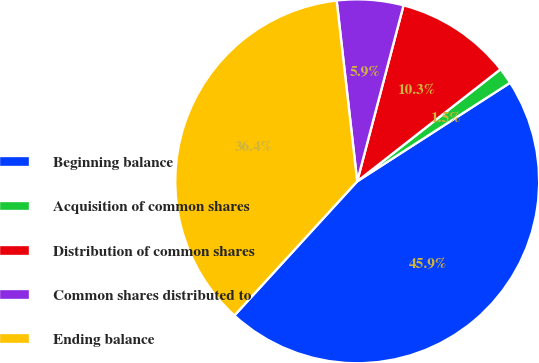Convert chart to OTSL. <chart><loc_0><loc_0><loc_500><loc_500><pie_chart><fcel>Beginning balance<fcel>Acquisition of common shares<fcel>Distribution of common shares<fcel>Common shares distributed to<fcel>Ending balance<nl><fcel>45.91%<fcel>1.45%<fcel>10.34%<fcel>5.9%<fcel>36.4%<nl></chart> 